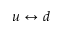<formula> <loc_0><loc_0><loc_500><loc_500>u \leftrightarrow d</formula> 